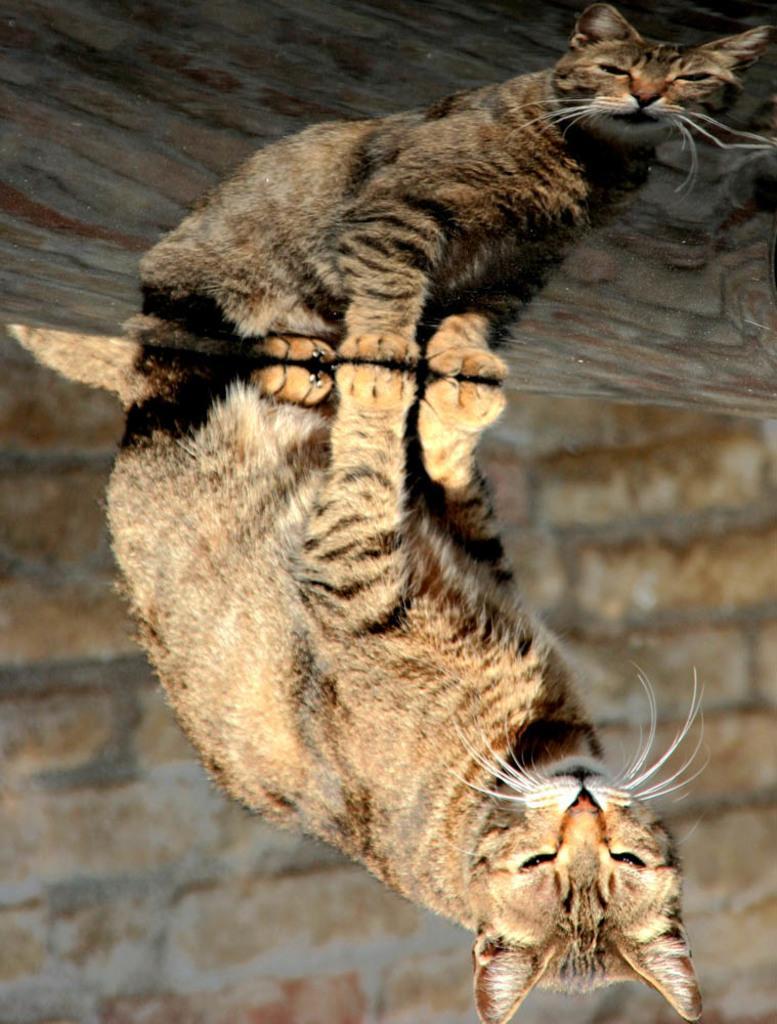Describe this image in one or two sentences. In this image we can see a cat and a wall. We can see the reflection of a cat and a wall in the image. 